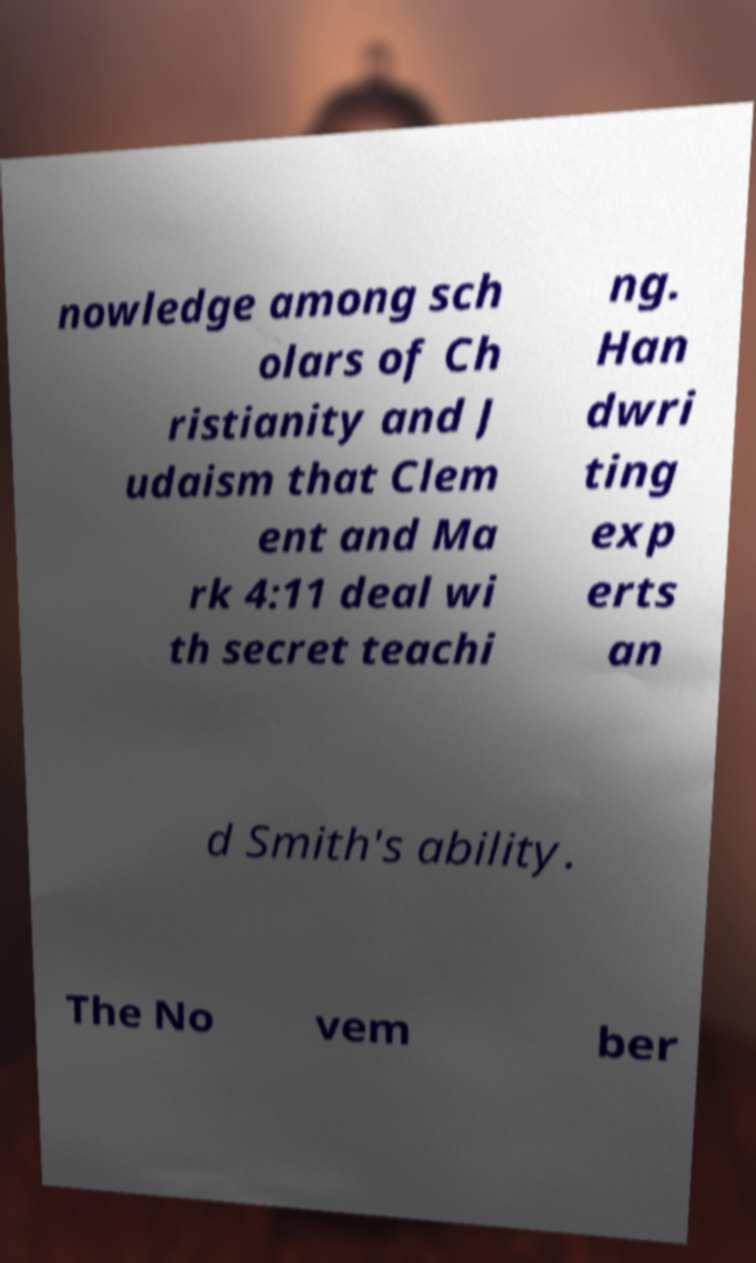There's text embedded in this image that I need extracted. Can you transcribe it verbatim? nowledge among sch olars of Ch ristianity and J udaism that Clem ent and Ma rk 4:11 deal wi th secret teachi ng. Han dwri ting exp erts an d Smith's ability. The No vem ber 